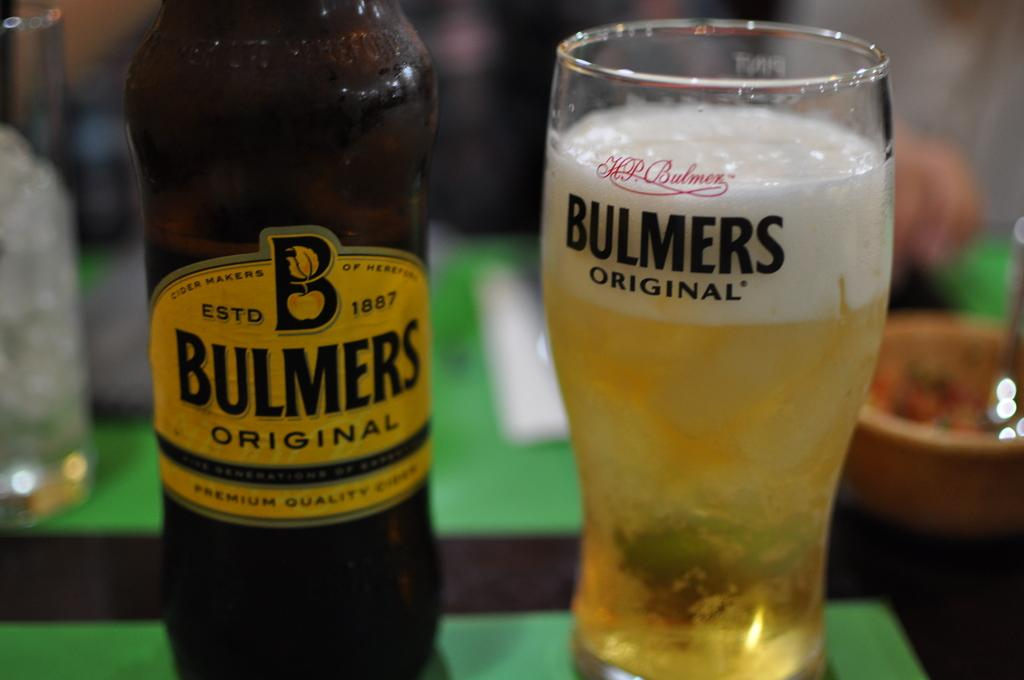<image>
Present a compact description of the photo's key features. A glass of beer sitting next to a bottle of Bulmers original. 